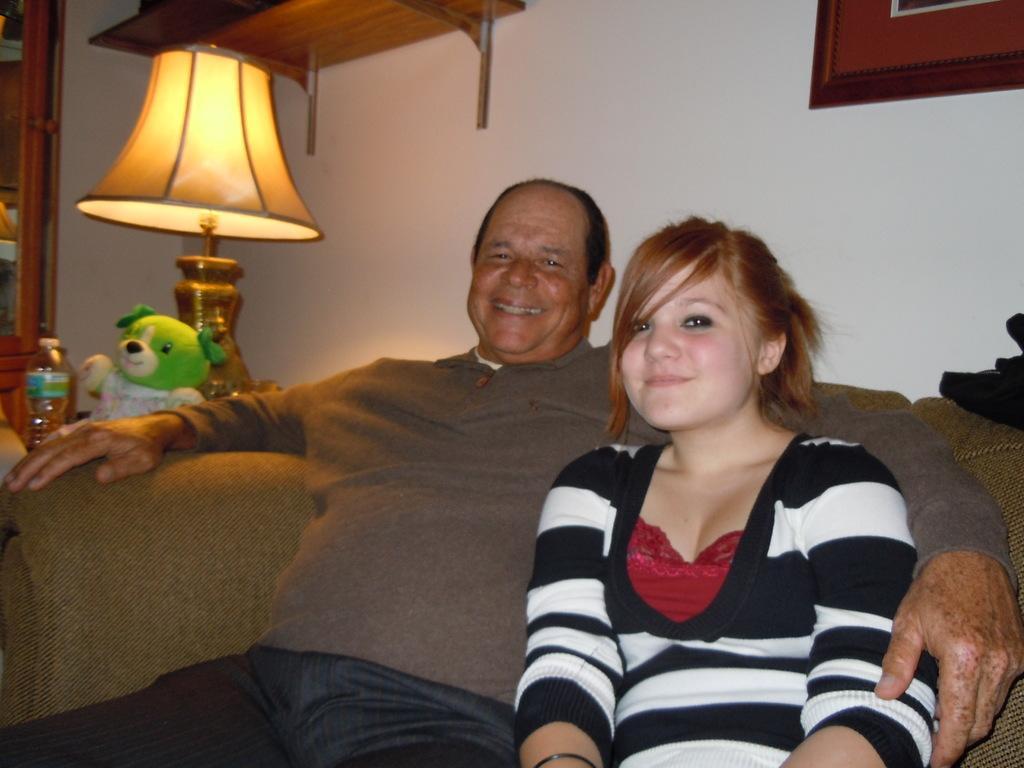How would you summarize this image in a sentence or two? In the foreground, I can see two persons are sitting on a sofa. In the background, I can see a toy, bottle and a lamp on a table and I can see a wall, wooden objects, door and a photo frame. This image taken, maybe in a room. 